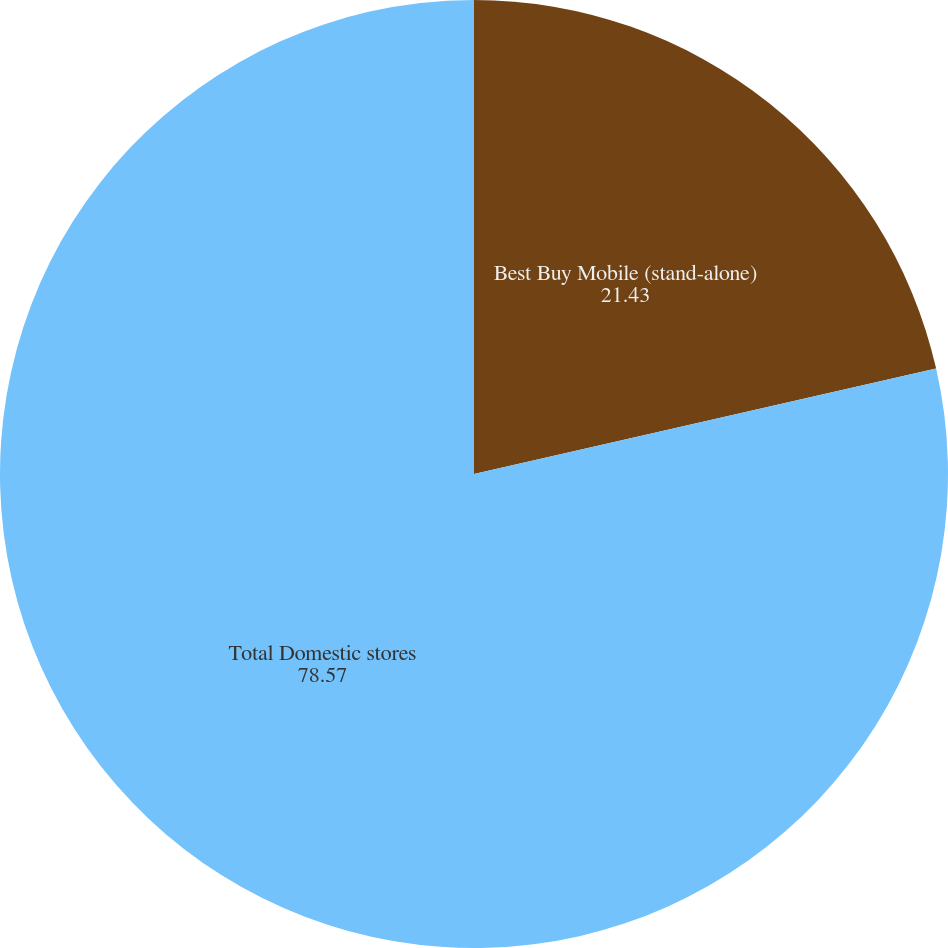Convert chart to OTSL. <chart><loc_0><loc_0><loc_500><loc_500><pie_chart><fcel>Best Buy Mobile (stand-alone)<fcel>Total Domestic stores<nl><fcel>21.43%<fcel>78.57%<nl></chart> 